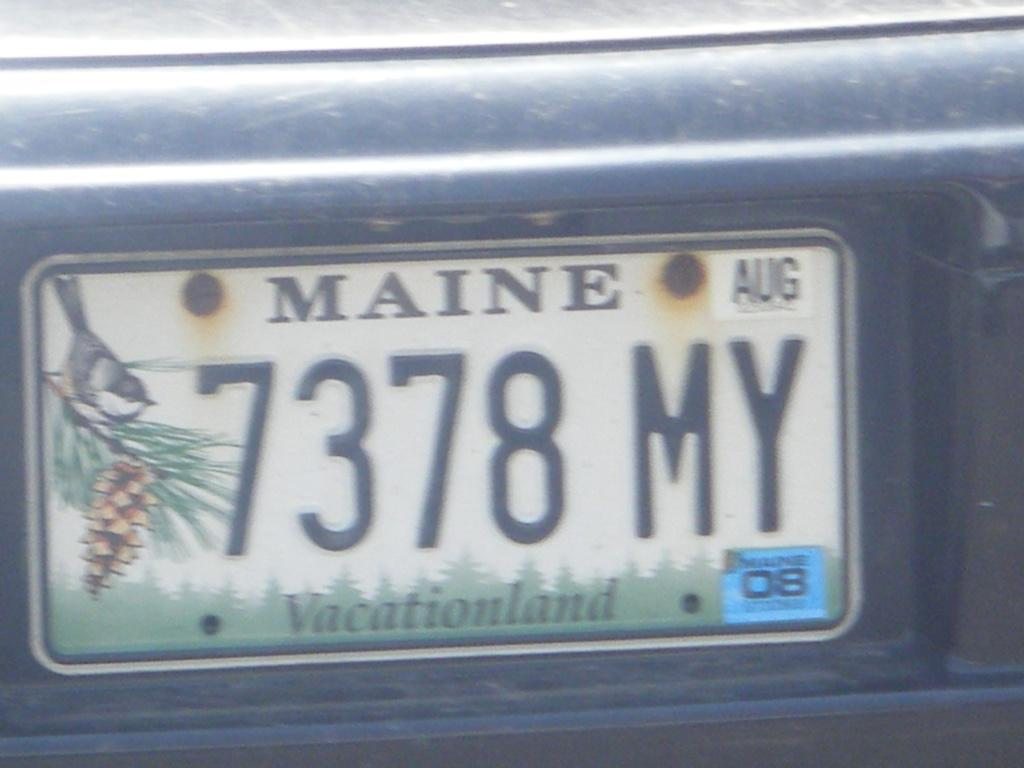Provide a one-sentence caption for the provided image. A license plate says Maine and the plate number is 7378 MY. 